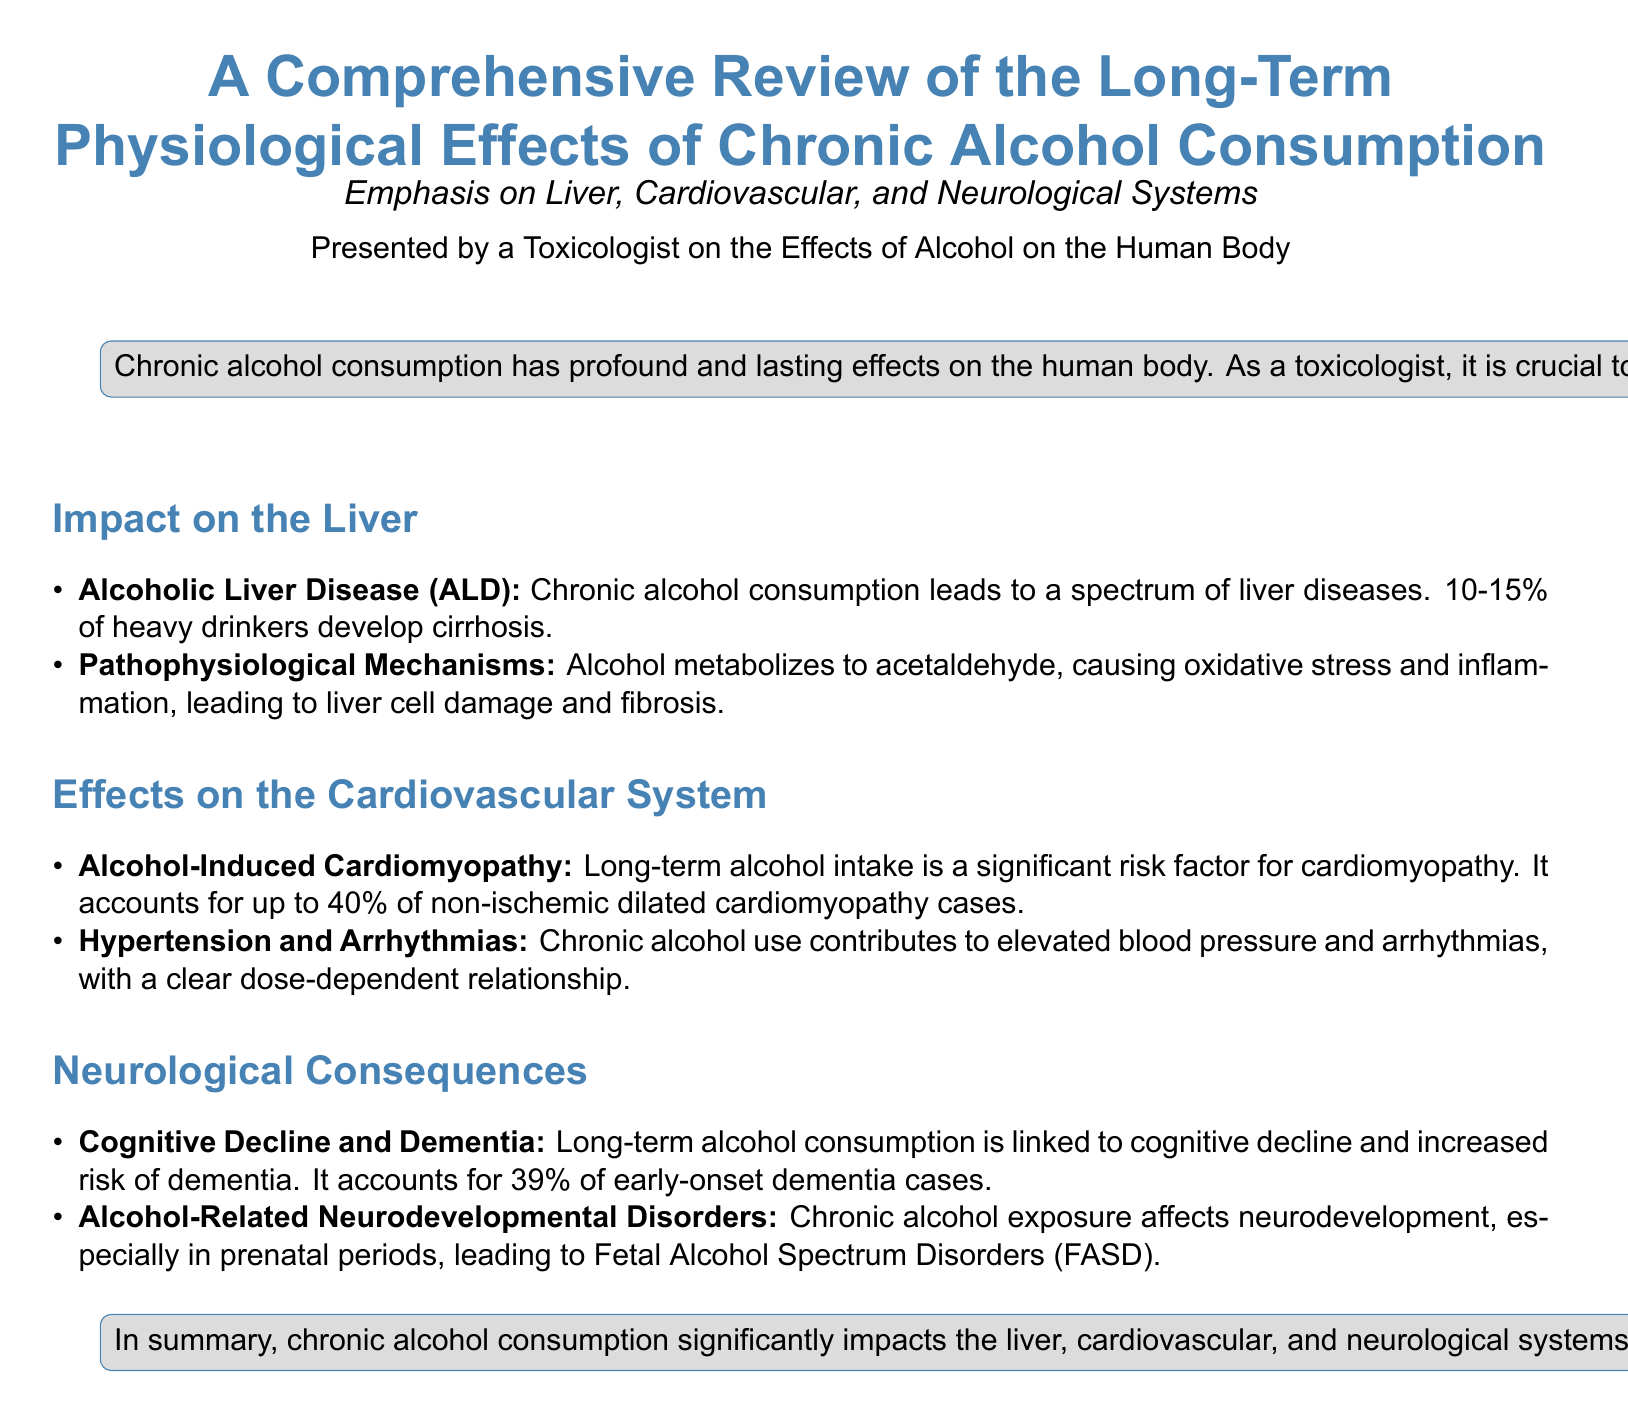What is the primary focus of the review? The review emphasizes the long-term physiological effects of chronic alcohol consumption on the liver, cardiovascular, and neurological systems.
Answer: long-term physiological effects of chronic alcohol consumption What percentage of heavy drinkers develop cirrhosis? The document states that 10-15% of heavy drinkers develop cirrhosis.
Answer: 10-15% What is a significant risk factor for alcohol-induced cardiomyopathy? Long-term alcohol intake is identified as a significant risk factor.
Answer: Long-term alcohol intake How much of early-onset dementia cases is accounted for by long-term alcohol consumption? The review mentions that long-term alcohol consumption accounts for 39% of early-onset dementia cases.
Answer: 39% What term describes the disorders caused by prenatal alcohol exposure? The document refers to these disorders as Fetal Alcohol Spectrum Disorders (FASD).
Answer: Fetal Alcohol Spectrum Disorders What organ system is primarily affected by Alcoholic Liver Disease (ALD)? Alcoholic Liver Disease (ALD) primarily affects the liver.
Answer: liver What relationship is noted between chronic alcohol use and blood pressure? There is a clear dose-dependent relationship between chronic alcohol use and elevated blood pressure.
Answer: dose-dependent relationship What are two neurological consequences of chronic alcohol consumption mentioned in the document? The document lists cognitive decline and dementia as neurological consequences.
Answer: cognitive decline and dementia 